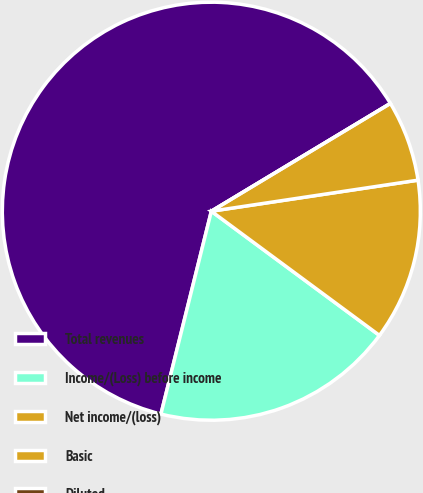<chart> <loc_0><loc_0><loc_500><loc_500><pie_chart><fcel>Total revenues<fcel>Income/(Loss) before income<fcel>Net income/(loss)<fcel>Basic<fcel>Diluted<nl><fcel>62.5%<fcel>18.75%<fcel>12.5%<fcel>6.25%<fcel>0.0%<nl></chart> 